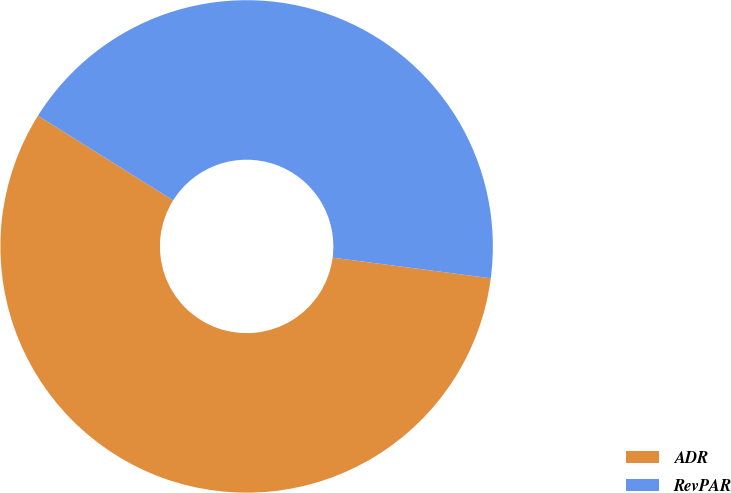Convert chart. <chart><loc_0><loc_0><loc_500><loc_500><pie_chart><fcel>ADR<fcel>RevPAR<nl><fcel>56.84%<fcel>43.16%<nl></chart> 